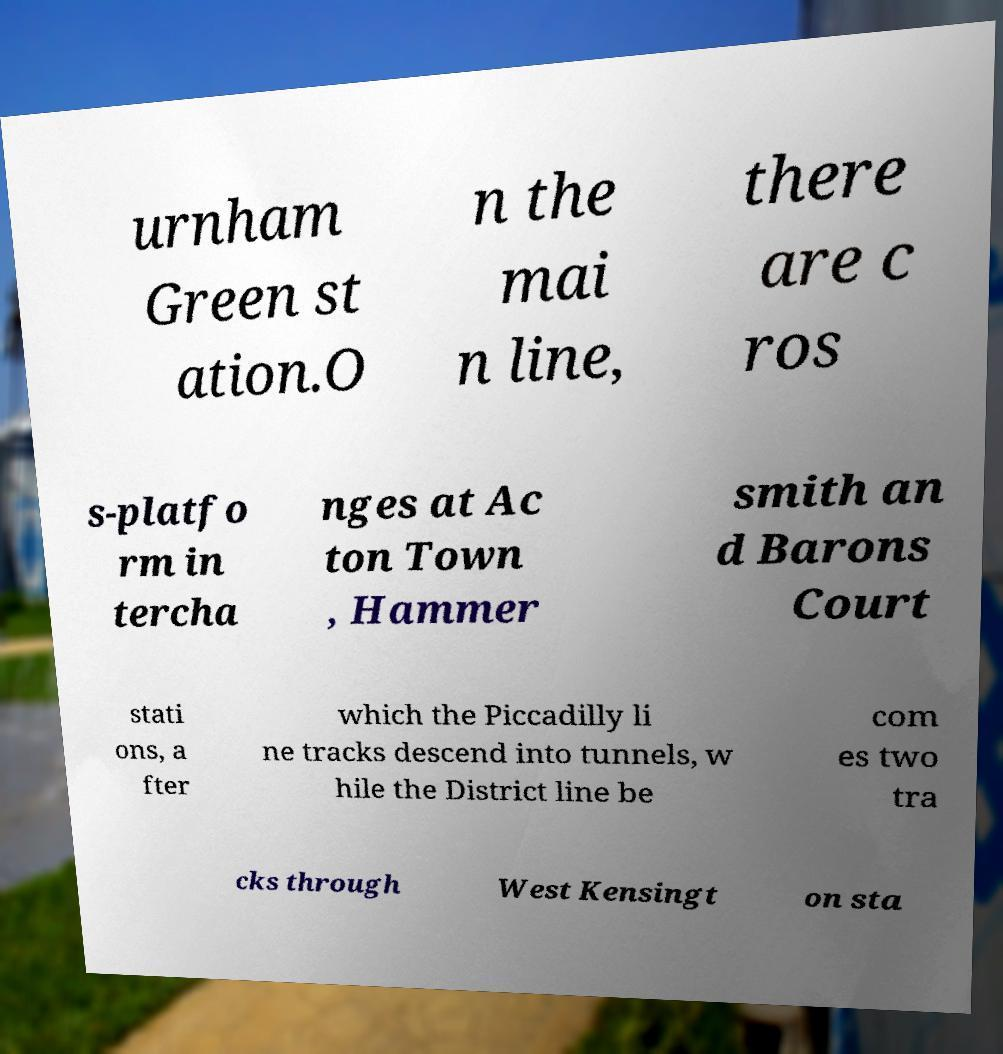Could you assist in decoding the text presented in this image and type it out clearly? urnham Green st ation.O n the mai n line, there are c ros s-platfo rm in tercha nges at Ac ton Town , Hammer smith an d Barons Court stati ons, a fter which the Piccadilly li ne tracks descend into tunnels, w hile the District line be com es two tra cks through West Kensingt on sta 